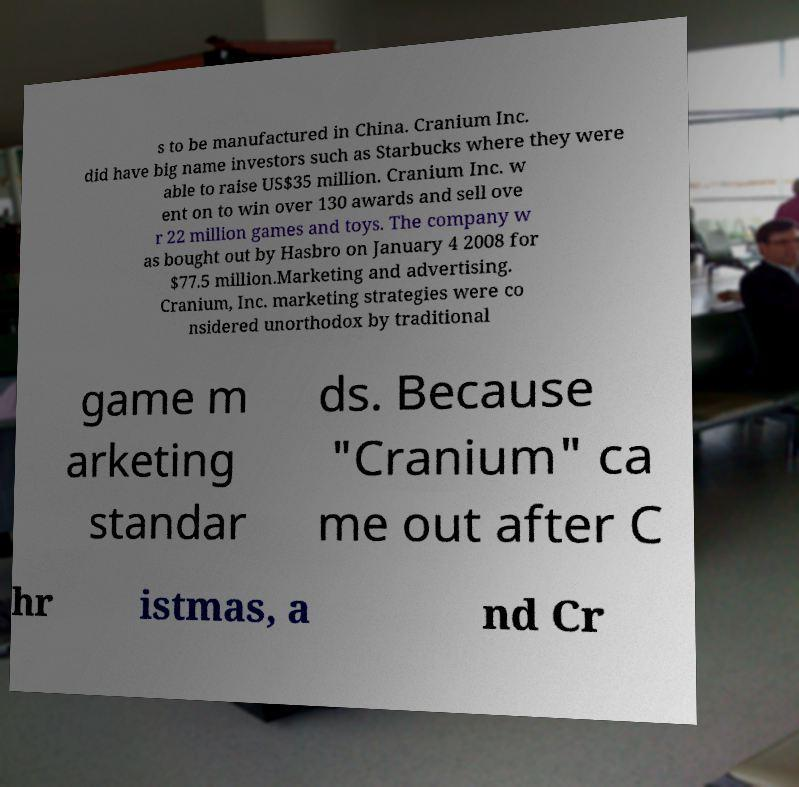For documentation purposes, I need the text within this image transcribed. Could you provide that? s to be manufactured in China. Cranium Inc. did have big name investors such as Starbucks where they were able to raise US$35 million. Cranium Inc. w ent on to win over 130 awards and sell ove r 22 million games and toys. The company w as bought out by Hasbro on January 4 2008 for $77.5 million.Marketing and advertising. Cranium, Inc. marketing strategies were co nsidered unorthodox by traditional game m arketing standar ds. Because "Cranium" ca me out after C hr istmas, a nd Cr 